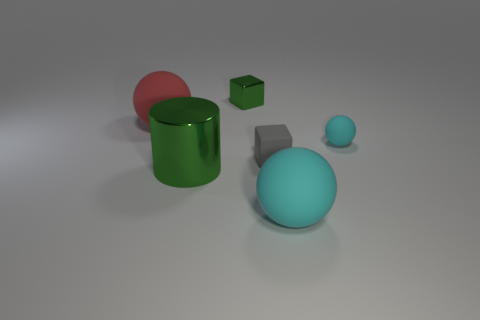Do the green thing that is behind the gray rubber object and the large red object have the same shape?
Provide a short and direct response. No. Is the number of small gray rubber blocks to the left of the large red rubber object less than the number of red rubber things?
Provide a succinct answer. Yes. Are there any cubes made of the same material as the large green thing?
Offer a very short reply. Yes. There is a ball that is the same size as the red object; what material is it?
Your answer should be compact. Rubber. Is the number of cyan matte objects that are on the right side of the large cyan object less than the number of matte things that are in front of the small ball?
Make the answer very short. Yes. There is a object that is both behind the tiny gray matte thing and on the left side of the small green metal thing; what shape is it?
Make the answer very short. Sphere. What number of small gray objects have the same shape as the tiny cyan rubber object?
Offer a very short reply. 0. There is a red ball that is the same material as the tiny gray thing; what size is it?
Offer a terse response. Large. Are there more large cyan cubes than rubber things?
Make the answer very short. No. There is a matte object that is behind the tiny cyan matte ball; what is its color?
Offer a very short reply. Red. 